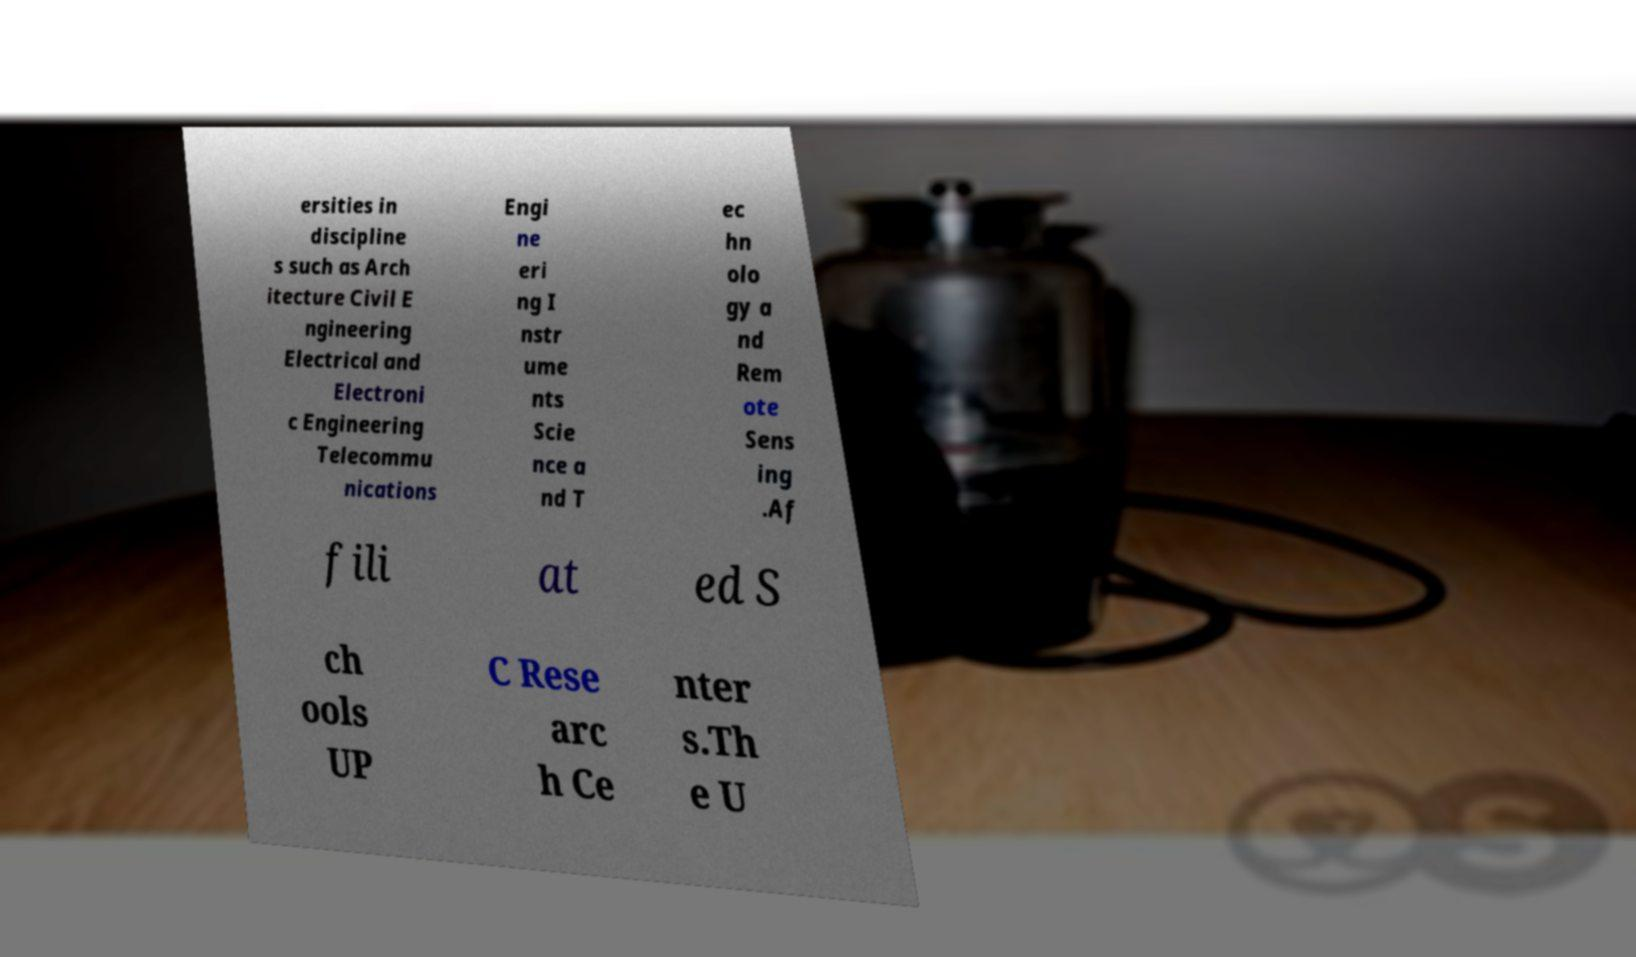I need the written content from this picture converted into text. Can you do that? ersities in discipline s such as Arch itecture Civil E ngineering Electrical and Electroni c Engineering Telecommu nications Engi ne eri ng I nstr ume nts Scie nce a nd T ec hn olo gy a nd Rem ote Sens ing .Af fili at ed S ch ools UP C Rese arc h Ce nter s.Th e U 